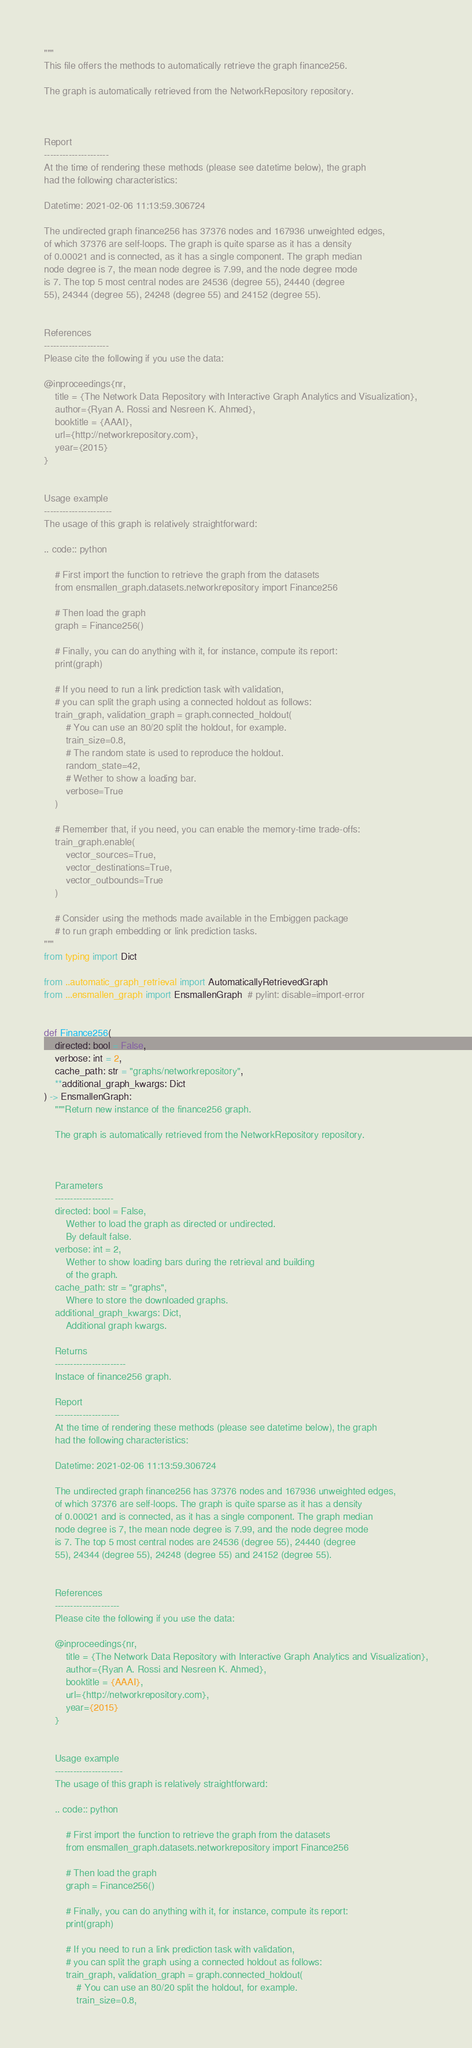Convert code to text. <code><loc_0><loc_0><loc_500><loc_500><_Python_>"""
This file offers the methods to automatically retrieve the graph finance256.

The graph is automatically retrieved from the NetworkRepository repository. 



Report
---------------------
At the time of rendering these methods (please see datetime below), the graph
had the following characteristics:

Datetime: 2021-02-06 11:13:59.306724

The undirected graph finance256 has 37376 nodes and 167936 unweighted edges,
of which 37376 are self-loops. The graph is quite sparse as it has a density
of 0.00021 and is connected, as it has a single component. The graph median
node degree is 7, the mean node degree is 7.99, and the node degree mode
is 7. The top 5 most central nodes are 24536 (degree 55), 24440 (degree
55), 24344 (degree 55), 24248 (degree 55) and 24152 (degree 55).


References
---------------------
Please cite the following if you use the data:

@inproceedings{nr,
    title = {The Network Data Repository with Interactive Graph Analytics and Visualization},
    author={Ryan A. Rossi and Nesreen K. Ahmed},
    booktitle = {AAAI},
    url={http://networkrepository.com},
    year={2015}
}


Usage example
----------------------
The usage of this graph is relatively straightforward:

.. code:: python

    # First import the function to retrieve the graph from the datasets
    from ensmallen_graph.datasets.networkrepository import Finance256

    # Then load the graph
    graph = Finance256()

    # Finally, you can do anything with it, for instance, compute its report:
    print(graph)

    # If you need to run a link prediction task with validation,
    # you can split the graph using a connected holdout as follows:
    train_graph, validation_graph = graph.connected_holdout(
        # You can use an 80/20 split the holdout, for example.
        train_size=0.8,
        # The random state is used to reproduce the holdout.
        random_state=42,
        # Wether to show a loading bar.
        verbose=True
    )

    # Remember that, if you need, you can enable the memory-time trade-offs:
    train_graph.enable(
        vector_sources=True,
        vector_destinations=True,
        vector_outbounds=True
    )

    # Consider using the methods made available in the Embiggen package
    # to run graph embedding or link prediction tasks.
"""
from typing import Dict

from ..automatic_graph_retrieval import AutomaticallyRetrievedGraph
from ...ensmallen_graph import EnsmallenGraph  # pylint: disable=import-error


def Finance256(
    directed: bool = False,
    verbose: int = 2,
    cache_path: str = "graphs/networkrepository",
    **additional_graph_kwargs: Dict
) -> EnsmallenGraph:
    """Return new instance of the finance256 graph.

    The graph is automatically retrieved from the NetworkRepository repository. 

	

    Parameters
    -------------------
    directed: bool = False,
        Wether to load the graph as directed or undirected.
        By default false.
    verbose: int = 2,
        Wether to show loading bars during the retrieval and building
        of the graph.
    cache_path: str = "graphs",
        Where to store the downloaded graphs.
    additional_graph_kwargs: Dict,
        Additional graph kwargs.

    Returns
    -----------------------
    Instace of finance256 graph.

	Report
	---------------------
	At the time of rendering these methods (please see datetime below), the graph
	had the following characteristics:
	
	Datetime: 2021-02-06 11:13:59.306724
	
	The undirected graph finance256 has 37376 nodes and 167936 unweighted edges,
	of which 37376 are self-loops. The graph is quite sparse as it has a density
	of 0.00021 and is connected, as it has a single component. The graph median
	node degree is 7, the mean node degree is 7.99, and the node degree mode
	is 7. The top 5 most central nodes are 24536 (degree 55), 24440 (degree
	55), 24344 (degree 55), 24248 (degree 55) and 24152 (degree 55).
	

	References
	---------------------
	Please cite the following if you use the data:
	
	@inproceedings{nr,
	    title = {The Network Data Repository with Interactive Graph Analytics and Visualization},
	    author={Ryan A. Rossi and Nesreen K. Ahmed},
	    booktitle = {AAAI},
	    url={http://networkrepository.com},
	    year={2015}
	}
	

	Usage example
	----------------------
	The usage of this graph is relatively straightforward:
	
	.. code:: python
	
	    # First import the function to retrieve the graph from the datasets
	    from ensmallen_graph.datasets.networkrepository import Finance256
	
	    # Then load the graph
	    graph = Finance256()
	
	    # Finally, you can do anything with it, for instance, compute its report:
	    print(graph)
	
	    # If you need to run a link prediction task with validation,
	    # you can split the graph using a connected holdout as follows:
	    train_graph, validation_graph = graph.connected_holdout(
	        # You can use an 80/20 split the holdout, for example.
	        train_size=0.8,</code> 